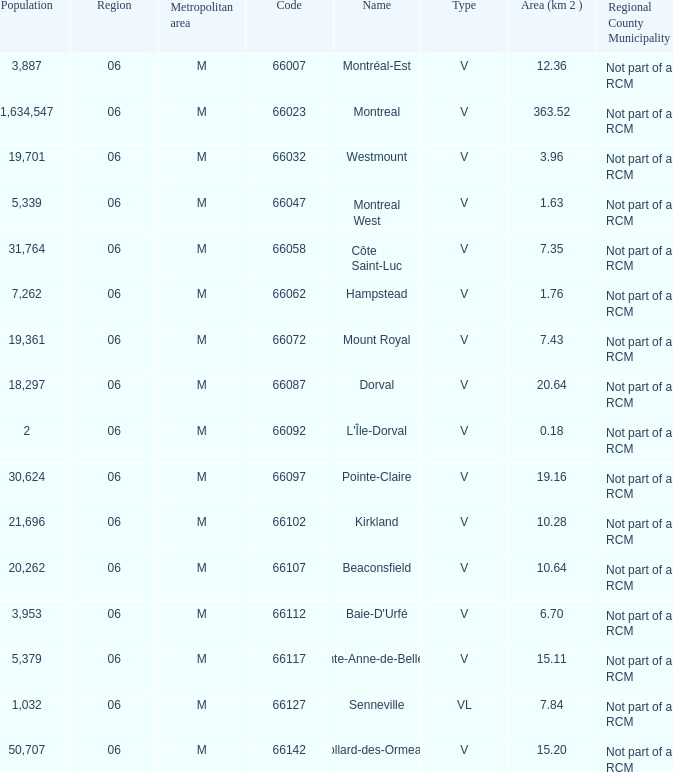Can you parse all the data within this table? {'header': ['Population', 'Region', 'Metropolitan area', 'Code', 'Name', 'Type', 'Area (km 2 )', 'Regional County Municipality'], 'rows': [['3,887', '06', 'M', '66007', 'Montréal-Est', 'V', '12.36', 'Not part of a RCM'], ['1,634,547', '06', 'M', '66023', 'Montreal', 'V', '363.52', 'Not part of a RCM'], ['19,701', '06', 'M', '66032', 'Westmount', 'V', '3.96', 'Not part of a RCM'], ['5,339', '06', 'M', '66047', 'Montreal West', 'V', '1.63', 'Not part of a RCM'], ['31,764', '06', 'M', '66058', 'Côte Saint-Luc', 'V', '7.35', 'Not part of a RCM'], ['7,262', '06', 'M', '66062', 'Hampstead', 'V', '1.76', 'Not part of a RCM'], ['19,361', '06', 'M', '66072', 'Mount Royal', 'V', '7.43', 'Not part of a RCM'], ['18,297', '06', 'M', '66087', 'Dorval', 'V', '20.64', 'Not part of a RCM'], ['2', '06', 'M', '66092', "L'Île-Dorval", 'V', '0.18', 'Not part of a RCM'], ['30,624', '06', 'M', '66097', 'Pointe-Claire', 'V', '19.16', 'Not part of a RCM'], ['21,696', '06', 'M', '66102', 'Kirkland', 'V', '10.28', 'Not part of a RCM'], ['20,262', '06', 'M', '66107', 'Beaconsfield', 'V', '10.64', 'Not part of a RCM'], ['3,953', '06', 'M', '66112', "Baie-D'Urfé", 'V', '6.70', 'Not part of a RCM'], ['5,379', '06', 'M', '66117', 'Sainte-Anne-de-Bellevue', 'V', '15.11', 'Not part of a RCM'], ['1,032', '06', 'M', '66127', 'Senneville', 'VL', '7.84', 'Not part of a RCM'], ['50,707', '06', 'M', '66142', 'Dollard-des-Ormeaux', 'V', '15.20', 'Not part of a RCM']]} What is the largest region with a Code smaller than 66112, and a Name of l'île-dorval? 6.0. 